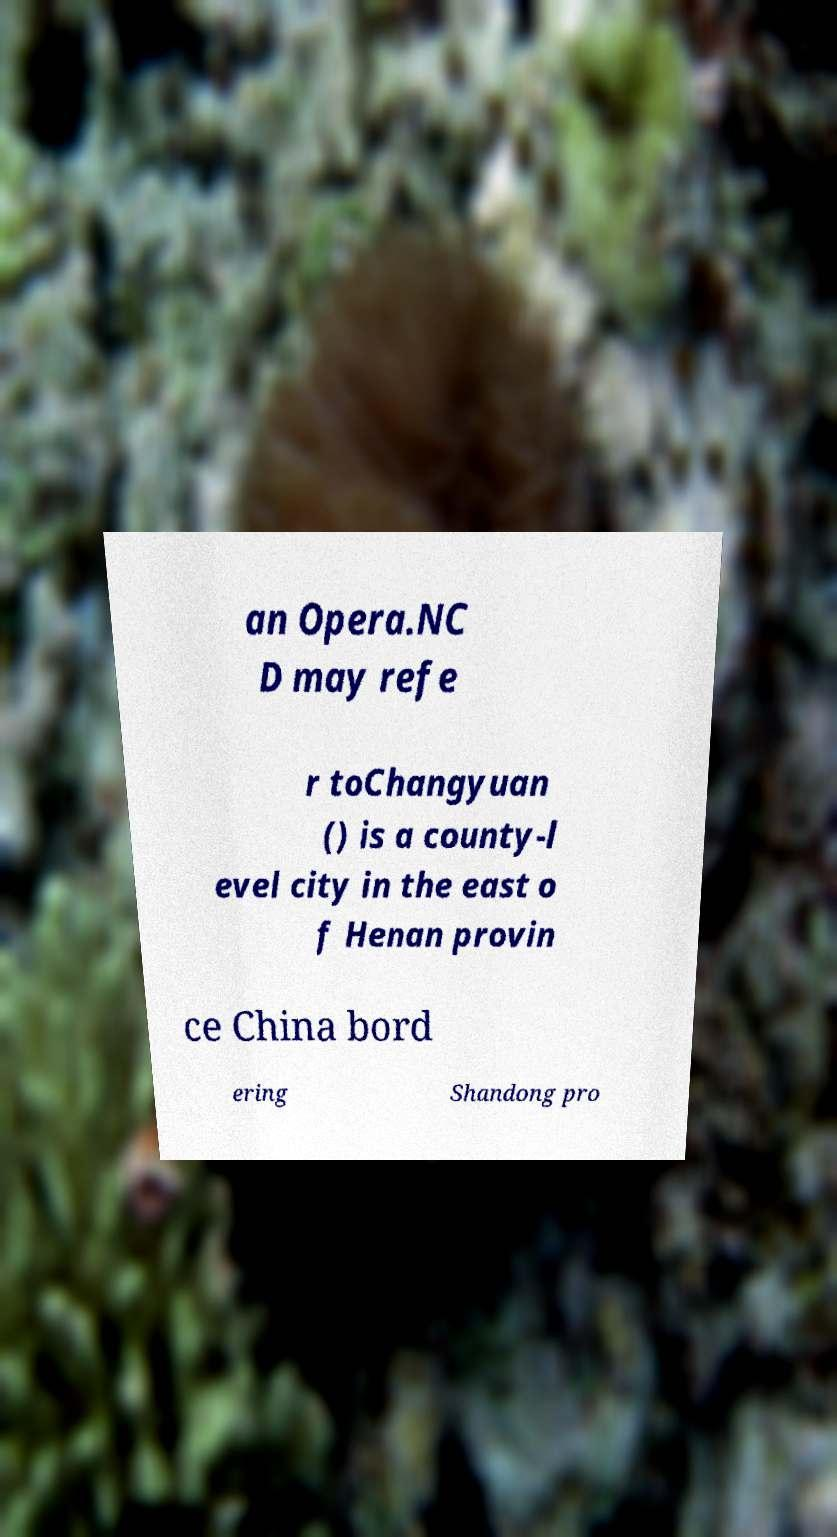Can you accurately transcribe the text from the provided image for me? an Opera.NC D may refe r toChangyuan () is a county-l evel city in the east o f Henan provin ce China bord ering Shandong pro 